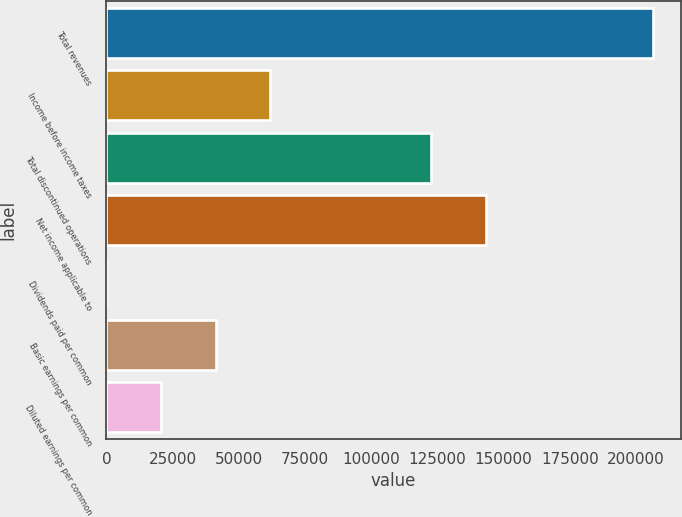Convert chart. <chart><loc_0><loc_0><loc_500><loc_500><bar_chart><fcel>Total revenues<fcel>Income before income taxes<fcel>Total discontinued operations<fcel>Net income applicable to<fcel>Dividends paid per common<fcel>Basic earnings per common<fcel>Diluted earnings per common<nl><fcel>206503<fcel>61951.2<fcel>122737<fcel>143387<fcel>0.45<fcel>41301<fcel>20650.7<nl></chart> 